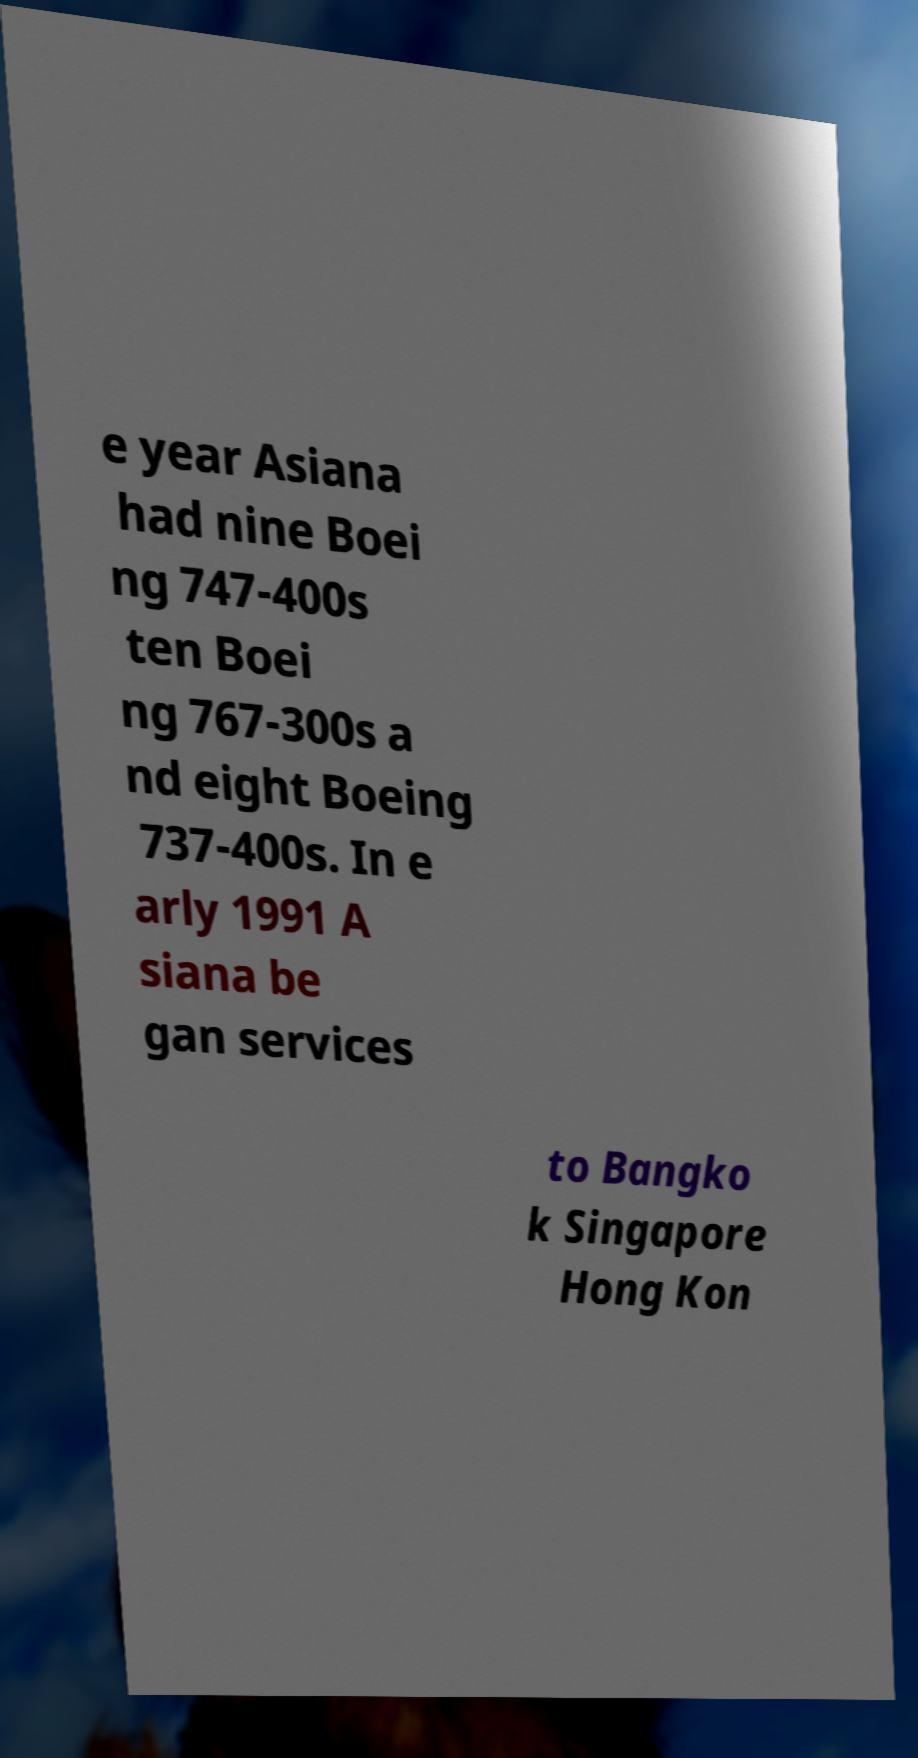I need the written content from this picture converted into text. Can you do that? e year Asiana had nine Boei ng 747-400s ten Boei ng 767-300s a nd eight Boeing 737-400s. In e arly 1991 A siana be gan services to Bangko k Singapore Hong Kon 